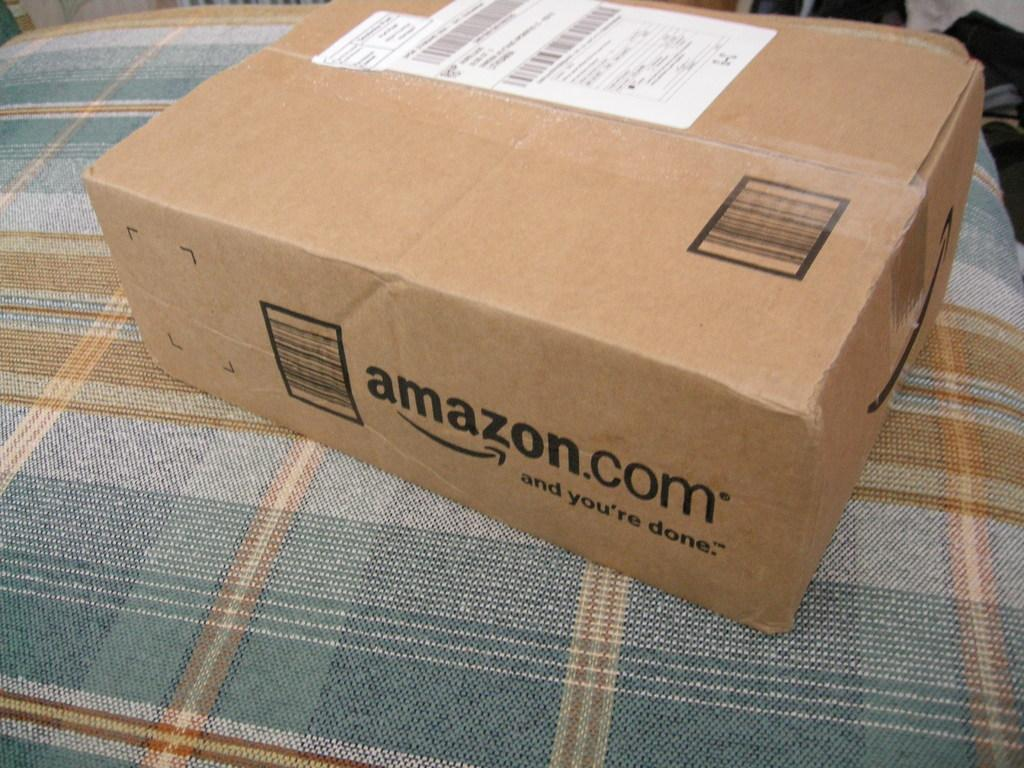<image>
Describe the image concisely. A brown, medium sized box containing the text, amazon.com and you're done on the outside edge. 